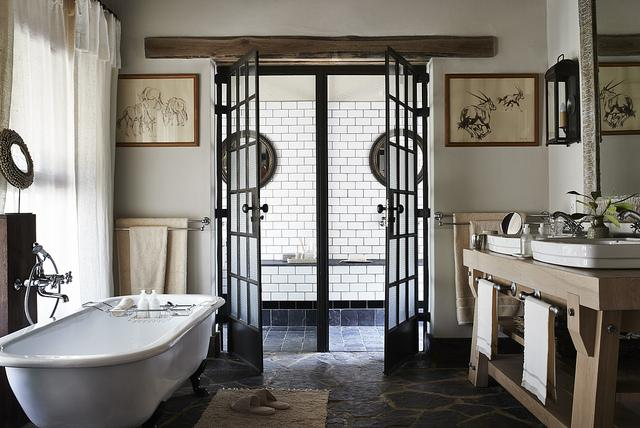The floor of the bathroom is made of what material? Please explain your reasoning. stone. The irregularly shaped pieces are cemented into place. 